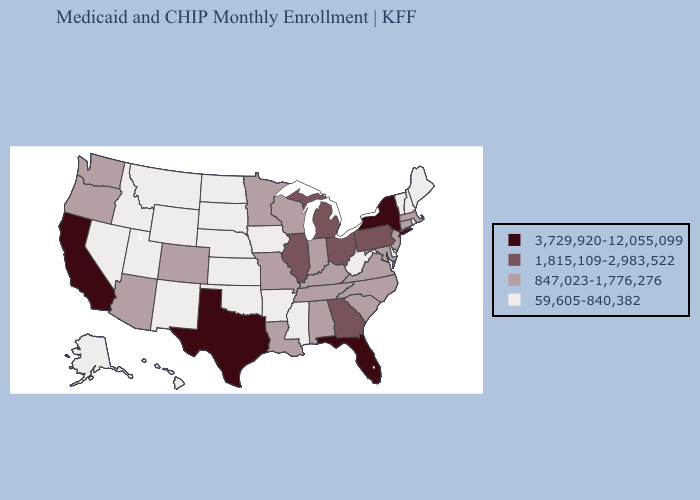What is the value of Georgia?
Concise answer only. 1,815,109-2,983,522. What is the highest value in the USA?
Short answer required. 3,729,920-12,055,099. Does Kentucky have a lower value than Pennsylvania?
Concise answer only. Yes. Among the states that border North Dakota , does Montana have the lowest value?
Concise answer only. Yes. Does North Dakota have a lower value than Maine?
Quick response, please. No. Does Washington have the same value as North Carolina?
Give a very brief answer. Yes. How many symbols are there in the legend?
Keep it brief. 4. Does Arkansas have the lowest value in the South?
Give a very brief answer. Yes. Does Wisconsin have the lowest value in the MidWest?
Short answer required. No. What is the lowest value in states that border Iowa?
Concise answer only. 59,605-840,382. Name the states that have a value in the range 1,815,109-2,983,522?
Keep it brief. Georgia, Illinois, Michigan, Ohio, Pennsylvania. Among the states that border Missouri , which have the highest value?
Answer briefly. Illinois. Name the states that have a value in the range 59,605-840,382?
Answer briefly. Alaska, Arkansas, Delaware, Hawaii, Idaho, Iowa, Kansas, Maine, Mississippi, Montana, Nebraska, Nevada, New Hampshire, New Mexico, North Dakota, Oklahoma, Rhode Island, South Dakota, Utah, Vermont, West Virginia, Wyoming. Among the states that border North Dakota , which have the lowest value?
Give a very brief answer. Montana, South Dakota. Does Virginia have a higher value than Nevada?
Write a very short answer. Yes. 